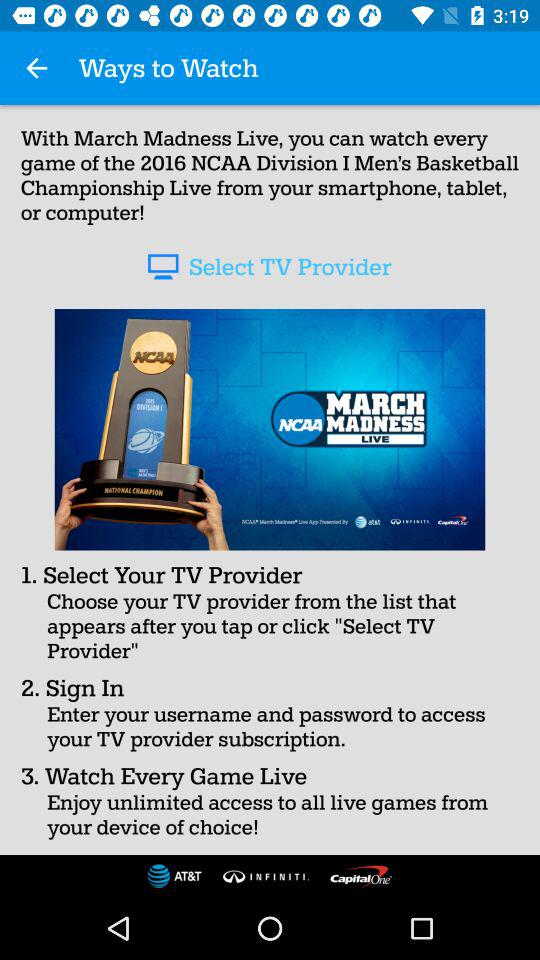How can we sign in? You can sign in by entering your username and password to access your TV provider subscription. 